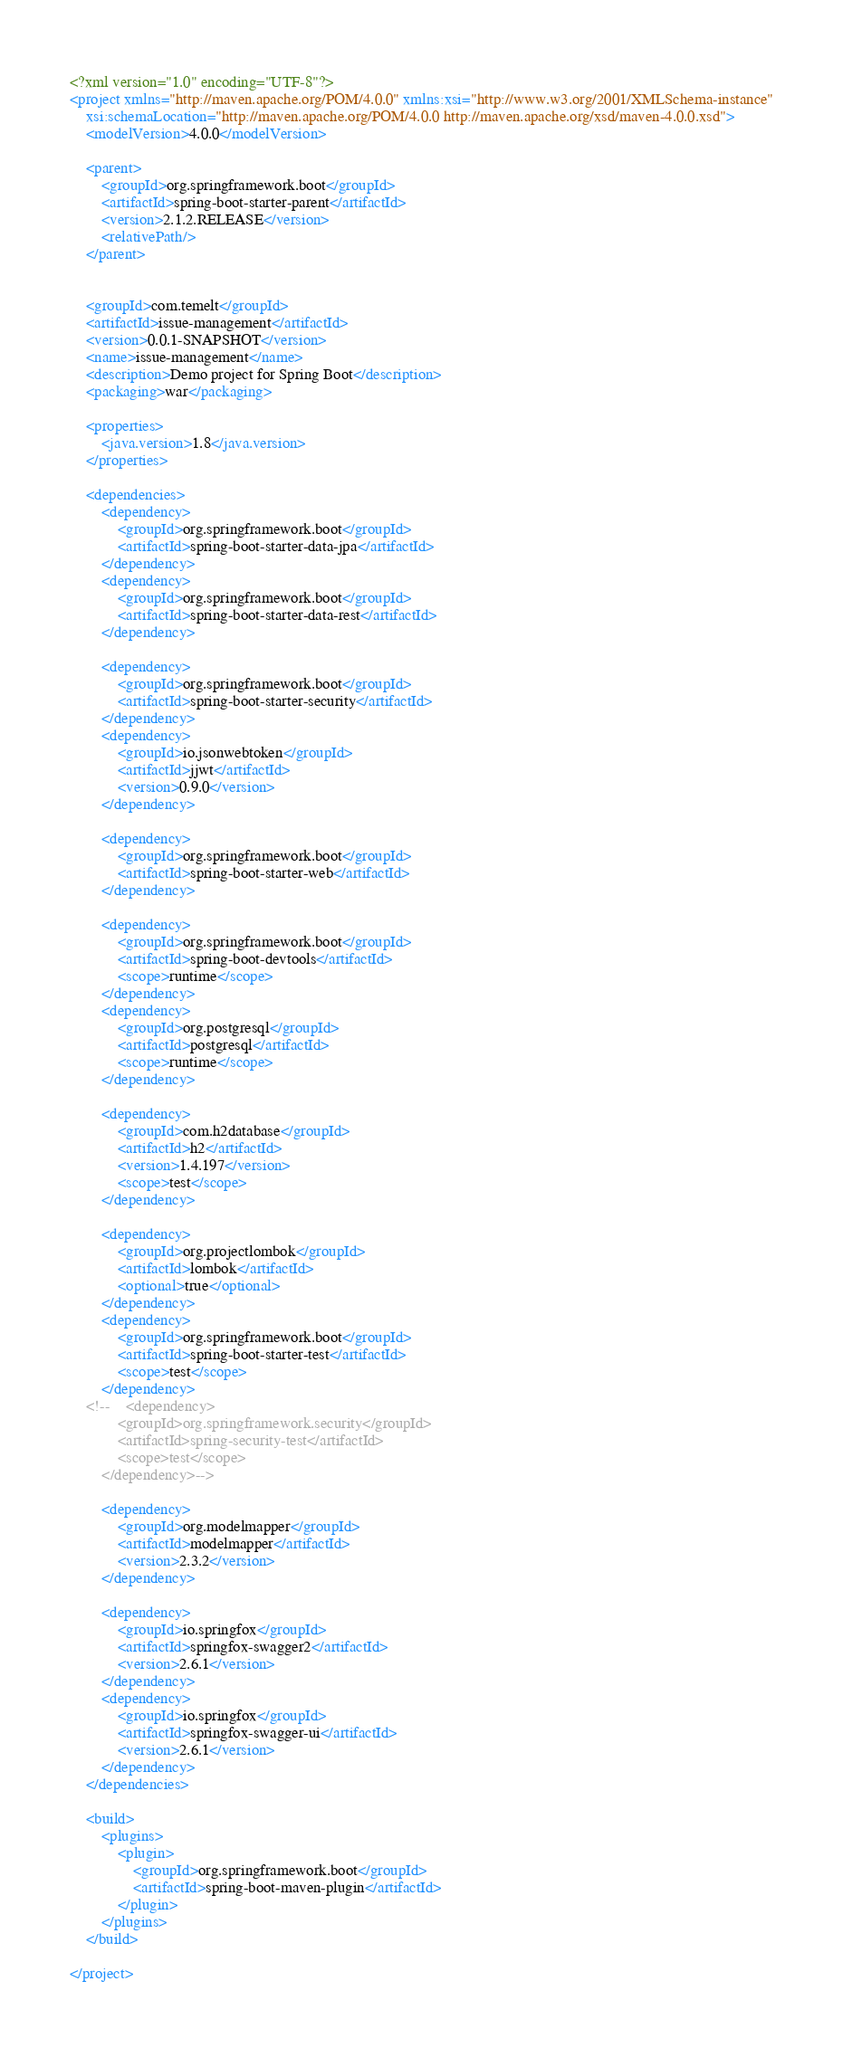<code> <loc_0><loc_0><loc_500><loc_500><_XML_><?xml version="1.0" encoding="UTF-8"?>
<project xmlns="http://maven.apache.org/POM/4.0.0" xmlns:xsi="http://www.w3.org/2001/XMLSchema-instance"
	xsi:schemaLocation="http://maven.apache.org/POM/4.0.0 http://maven.apache.org/xsd/maven-4.0.0.xsd">
	<modelVersion>4.0.0</modelVersion>

	<parent>
		<groupId>org.springframework.boot</groupId>
		<artifactId>spring-boot-starter-parent</artifactId>
		<version>2.1.2.RELEASE</version>
		<relativePath/>
	</parent>


	<groupId>com.temelt</groupId>
	<artifactId>issue-management</artifactId>
	<version>0.0.1-SNAPSHOT</version>
	<name>issue-management</name>
	<description>Demo project for Spring Boot</description>
	<packaging>war</packaging>

	<properties>
		<java.version>1.8</java.version>
	</properties>

	<dependencies>
		<dependency>
			<groupId>org.springframework.boot</groupId>
			<artifactId>spring-boot-starter-data-jpa</artifactId>
		</dependency>
		<dependency>
			<groupId>org.springframework.boot</groupId>
			<artifactId>spring-boot-starter-data-rest</artifactId>
		</dependency>

		<dependency>
			<groupId>org.springframework.boot</groupId>
			<artifactId>spring-boot-starter-security</artifactId>
		</dependency>
		<dependency>
			<groupId>io.jsonwebtoken</groupId>
			<artifactId>jjwt</artifactId>
			<version>0.9.0</version>
		</dependency>

		<dependency>
			<groupId>org.springframework.boot</groupId>
			<artifactId>spring-boot-starter-web</artifactId>
		</dependency>

		<dependency>
			<groupId>org.springframework.boot</groupId>
			<artifactId>spring-boot-devtools</artifactId>
			<scope>runtime</scope>
		</dependency>
		<dependency>
			<groupId>org.postgresql</groupId>
			<artifactId>postgresql</artifactId>
			<scope>runtime</scope>
		</dependency>

		<dependency>
			<groupId>com.h2database</groupId>
			<artifactId>h2</artifactId>
			<version>1.4.197</version>
			<scope>test</scope>
		</dependency>

		<dependency>
			<groupId>org.projectlombok</groupId>
			<artifactId>lombok</artifactId>
			<optional>true</optional>
		</dependency>
		<dependency>
			<groupId>org.springframework.boot</groupId>
			<artifactId>spring-boot-starter-test</artifactId>
			<scope>test</scope>
		</dependency>
	<!--	<dependency>
			<groupId>org.springframework.security</groupId>
			<artifactId>spring-security-test</artifactId>
			<scope>test</scope>
		</dependency>-->

		<dependency>
			<groupId>org.modelmapper</groupId>
			<artifactId>modelmapper</artifactId>
			<version>2.3.2</version>
		</dependency>

		<dependency>
			<groupId>io.springfox</groupId>
			<artifactId>springfox-swagger2</artifactId>
			<version>2.6.1</version>
		</dependency>
		<dependency>
			<groupId>io.springfox</groupId>
			<artifactId>springfox-swagger-ui</artifactId>
			<version>2.6.1</version>
		</dependency>
	</dependencies>

	<build>
		<plugins>
			<plugin>
				<groupId>org.springframework.boot</groupId>
				<artifactId>spring-boot-maven-plugin</artifactId>
			</plugin>
		</plugins>
	</build>

</project>
</code> 